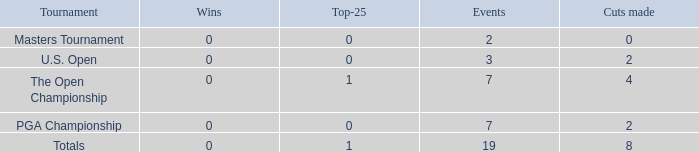What is the lowest position in the top-25 with negative wins? None. 